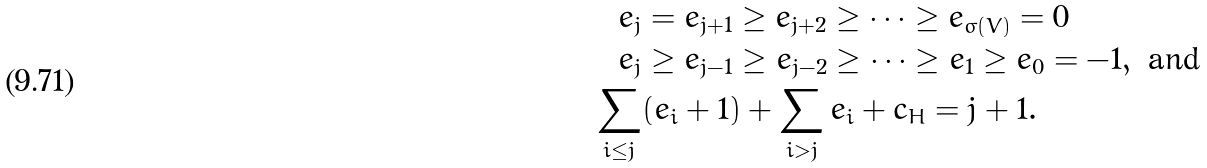<formula> <loc_0><loc_0><loc_500><loc_500>e _ { j } & = e _ { j + 1 } \geq e _ { j + 2 } \geq \cdots \geq e _ { \sigma ( V ) } = 0 \\ e _ { j } & \geq e _ { j - 1 } \geq e _ { j - 2 } \geq \cdots \geq e _ { 1 } \geq e _ { 0 } = - 1 , \text { and } \\ \sum _ { i \leq j } & ( e _ { i } + 1 ) + \sum _ { i > j } e _ { i } + c _ { H } = j + 1 .</formula> 